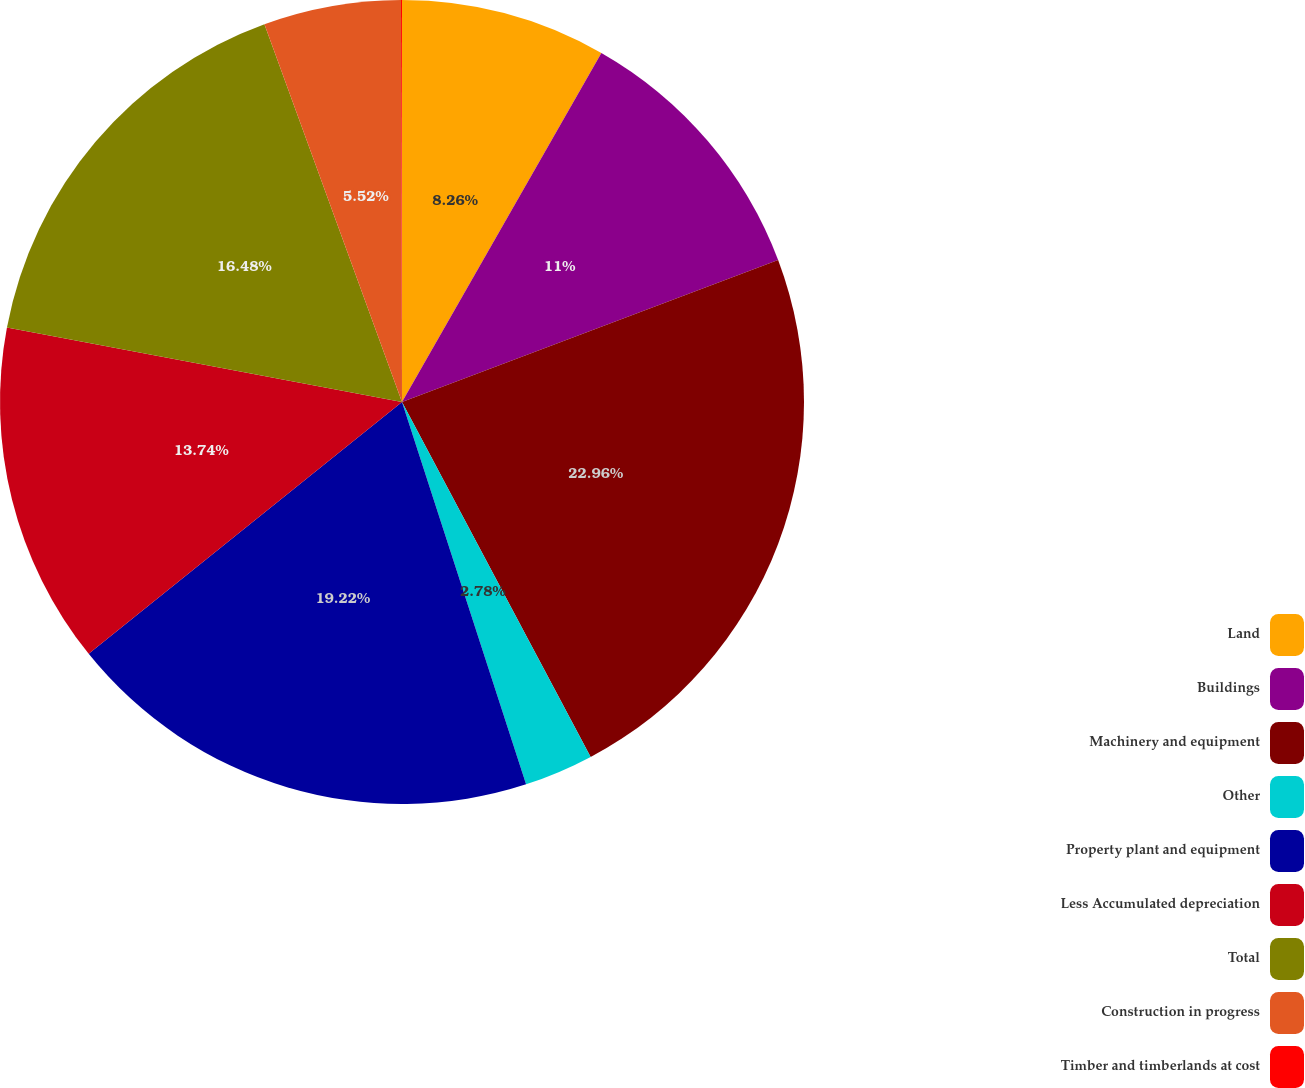Convert chart to OTSL. <chart><loc_0><loc_0><loc_500><loc_500><pie_chart><fcel>Land<fcel>Buildings<fcel>Machinery and equipment<fcel>Other<fcel>Property plant and equipment<fcel>Less Accumulated depreciation<fcel>Total<fcel>Construction in progress<fcel>Timber and timberlands at cost<nl><fcel>8.26%<fcel>11.0%<fcel>22.97%<fcel>2.78%<fcel>19.22%<fcel>13.74%<fcel>16.48%<fcel>5.52%<fcel>0.04%<nl></chart> 